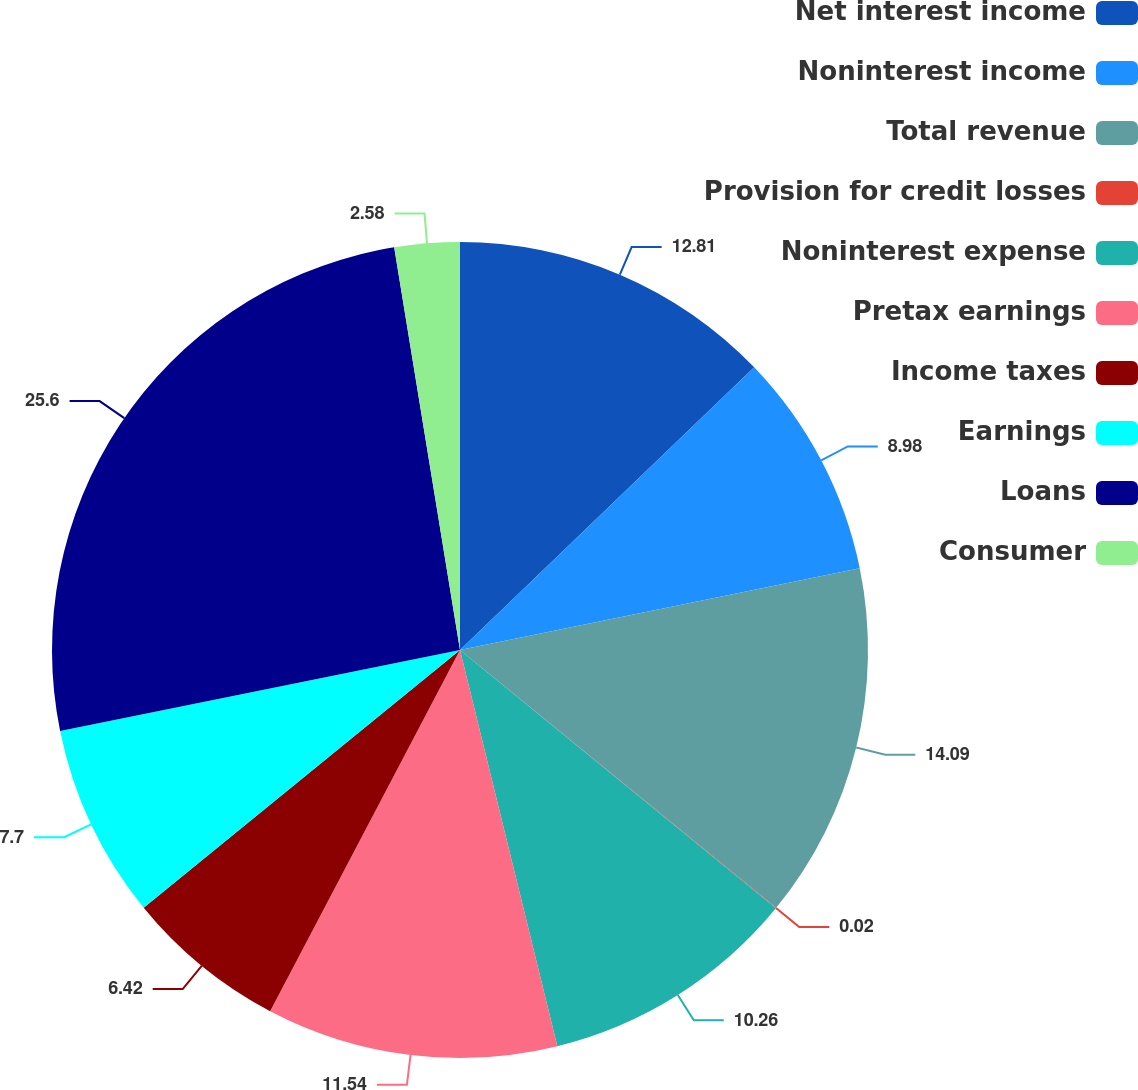<chart> <loc_0><loc_0><loc_500><loc_500><pie_chart><fcel>Net interest income<fcel>Noninterest income<fcel>Total revenue<fcel>Provision for credit losses<fcel>Noninterest expense<fcel>Pretax earnings<fcel>Income taxes<fcel>Earnings<fcel>Loans<fcel>Consumer<nl><fcel>12.82%<fcel>8.98%<fcel>14.1%<fcel>0.02%<fcel>10.26%<fcel>11.54%<fcel>6.42%<fcel>7.7%<fcel>25.61%<fcel>2.58%<nl></chart> 